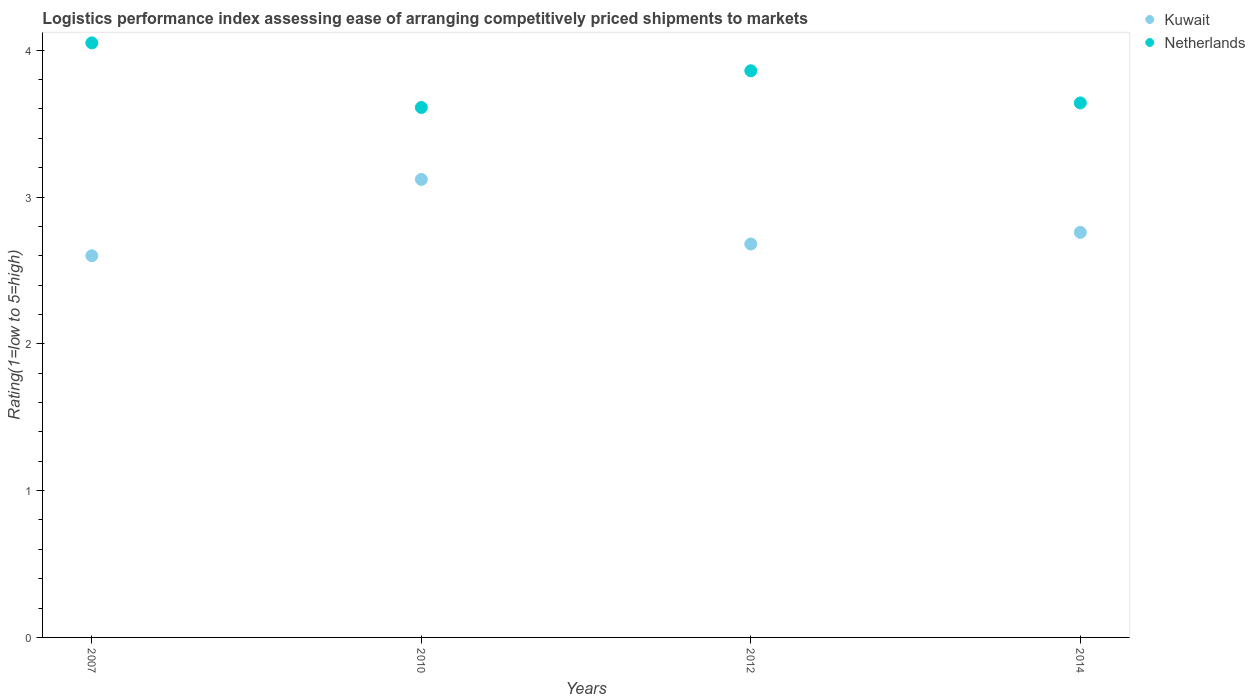How many different coloured dotlines are there?
Provide a short and direct response. 2. What is the Logistic performance index in Netherlands in 2010?
Keep it short and to the point. 3.61. Across all years, what is the maximum Logistic performance index in Kuwait?
Ensure brevity in your answer.  3.12. Across all years, what is the minimum Logistic performance index in Kuwait?
Offer a terse response. 2.6. In which year was the Logistic performance index in Netherlands minimum?
Offer a terse response. 2010. What is the total Logistic performance index in Kuwait in the graph?
Make the answer very short. 11.16. What is the difference between the Logistic performance index in Kuwait in 2012 and that in 2014?
Offer a terse response. -0.08. What is the difference between the Logistic performance index in Kuwait in 2014 and the Logistic performance index in Netherlands in 2007?
Ensure brevity in your answer.  -1.29. What is the average Logistic performance index in Kuwait per year?
Ensure brevity in your answer.  2.79. In the year 2014, what is the difference between the Logistic performance index in Netherlands and Logistic performance index in Kuwait?
Give a very brief answer. 0.88. What is the ratio of the Logistic performance index in Netherlands in 2010 to that in 2012?
Provide a succinct answer. 0.94. What is the difference between the highest and the second highest Logistic performance index in Netherlands?
Offer a very short reply. 0.19. What is the difference between the highest and the lowest Logistic performance index in Netherlands?
Your response must be concise. 0.44. Is the sum of the Logistic performance index in Netherlands in 2007 and 2012 greater than the maximum Logistic performance index in Kuwait across all years?
Provide a short and direct response. Yes. Is the Logistic performance index in Netherlands strictly greater than the Logistic performance index in Kuwait over the years?
Make the answer very short. Yes. Is the Logistic performance index in Kuwait strictly less than the Logistic performance index in Netherlands over the years?
Your response must be concise. Yes. Are the values on the major ticks of Y-axis written in scientific E-notation?
Provide a succinct answer. No. Does the graph contain grids?
Offer a terse response. No. Where does the legend appear in the graph?
Provide a short and direct response. Top right. What is the title of the graph?
Make the answer very short. Logistics performance index assessing ease of arranging competitively priced shipments to markets. What is the label or title of the X-axis?
Offer a very short reply. Years. What is the label or title of the Y-axis?
Offer a very short reply. Rating(1=low to 5=high). What is the Rating(1=low to 5=high) of Netherlands in 2007?
Ensure brevity in your answer.  4.05. What is the Rating(1=low to 5=high) of Kuwait in 2010?
Offer a very short reply. 3.12. What is the Rating(1=low to 5=high) in Netherlands in 2010?
Your response must be concise. 3.61. What is the Rating(1=low to 5=high) in Kuwait in 2012?
Make the answer very short. 2.68. What is the Rating(1=low to 5=high) in Netherlands in 2012?
Offer a terse response. 3.86. What is the Rating(1=low to 5=high) in Kuwait in 2014?
Offer a very short reply. 2.76. What is the Rating(1=low to 5=high) of Netherlands in 2014?
Make the answer very short. 3.64. Across all years, what is the maximum Rating(1=low to 5=high) in Kuwait?
Keep it short and to the point. 3.12. Across all years, what is the maximum Rating(1=low to 5=high) of Netherlands?
Offer a very short reply. 4.05. Across all years, what is the minimum Rating(1=low to 5=high) of Kuwait?
Your response must be concise. 2.6. Across all years, what is the minimum Rating(1=low to 5=high) in Netherlands?
Ensure brevity in your answer.  3.61. What is the total Rating(1=low to 5=high) of Kuwait in the graph?
Provide a succinct answer. 11.16. What is the total Rating(1=low to 5=high) of Netherlands in the graph?
Provide a short and direct response. 15.16. What is the difference between the Rating(1=low to 5=high) in Kuwait in 2007 and that in 2010?
Your answer should be very brief. -0.52. What is the difference between the Rating(1=low to 5=high) in Netherlands in 2007 and that in 2010?
Ensure brevity in your answer.  0.44. What is the difference between the Rating(1=low to 5=high) of Kuwait in 2007 and that in 2012?
Your response must be concise. -0.08. What is the difference between the Rating(1=low to 5=high) in Netherlands in 2007 and that in 2012?
Provide a succinct answer. 0.19. What is the difference between the Rating(1=low to 5=high) in Kuwait in 2007 and that in 2014?
Give a very brief answer. -0.16. What is the difference between the Rating(1=low to 5=high) of Netherlands in 2007 and that in 2014?
Provide a succinct answer. 0.41. What is the difference between the Rating(1=low to 5=high) of Kuwait in 2010 and that in 2012?
Provide a short and direct response. 0.44. What is the difference between the Rating(1=low to 5=high) of Netherlands in 2010 and that in 2012?
Offer a terse response. -0.25. What is the difference between the Rating(1=low to 5=high) of Kuwait in 2010 and that in 2014?
Make the answer very short. 0.36. What is the difference between the Rating(1=low to 5=high) of Netherlands in 2010 and that in 2014?
Your response must be concise. -0.03. What is the difference between the Rating(1=low to 5=high) of Kuwait in 2012 and that in 2014?
Provide a short and direct response. -0.08. What is the difference between the Rating(1=low to 5=high) in Netherlands in 2012 and that in 2014?
Provide a short and direct response. 0.22. What is the difference between the Rating(1=low to 5=high) in Kuwait in 2007 and the Rating(1=low to 5=high) in Netherlands in 2010?
Ensure brevity in your answer.  -1.01. What is the difference between the Rating(1=low to 5=high) of Kuwait in 2007 and the Rating(1=low to 5=high) of Netherlands in 2012?
Your answer should be very brief. -1.26. What is the difference between the Rating(1=low to 5=high) of Kuwait in 2007 and the Rating(1=low to 5=high) of Netherlands in 2014?
Offer a very short reply. -1.04. What is the difference between the Rating(1=low to 5=high) of Kuwait in 2010 and the Rating(1=low to 5=high) of Netherlands in 2012?
Your answer should be compact. -0.74. What is the difference between the Rating(1=low to 5=high) of Kuwait in 2010 and the Rating(1=low to 5=high) of Netherlands in 2014?
Keep it short and to the point. -0.52. What is the difference between the Rating(1=low to 5=high) in Kuwait in 2012 and the Rating(1=low to 5=high) in Netherlands in 2014?
Offer a very short reply. -0.96. What is the average Rating(1=low to 5=high) of Kuwait per year?
Offer a terse response. 2.79. What is the average Rating(1=low to 5=high) of Netherlands per year?
Ensure brevity in your answer.  3.79. In the year 2007, what is the difference between the Rating(1=low to 5=high) in Kuwait and Rating(1=low to 5=high) in Netherlands?
Provide a succinct answer. -1.45. In the year 2010, what is the difference between the Rating(1=low to 5=high) in Kuwait and Rating(1=low to 5=high) in Netherlands?
Make the answer very short. -0.49. In the year 2012, what is the difference between the Rating(1=low to 5=high) of Kuwait and Rating(1=low to 5=high) of Netherlands?
Give a very brief answer. -1.18. In the year 2014, what is the difference between the Rating(1=low to 5=high) in Kuwait and Rating(1=low to 5=high) in Netherlands?
Your answer should be compact. -0.88. What is the ratio of the Rating(1=low to 5=high) of Kuwait in 2007 to that in 2010?
Offer a very short reply. 0.83. What is the ratio of the Rating(1=low to 5=high) in Netherlands in 2007 to that in 2010?
Ensure brevity in your answer.  1.12. What is the ratio of the Rating(1=low to 5=high) in Kuwait in 2007 to that in 2012?
Provide a succinct answer. 0.97. What is the ratio of the Rating(1=low to 5=high) in Netherlands in 2007 to that in 2012?
Offer a very short reply. 1.05. What is the ratio of the Rating(1=low to 5=high) of Kuwait in 2007 to that in 2014?
Your answer should be very brief. 0.94. What is the ratio of the Rating(1=low to 5=high) in Netherlands in 2007 to that in 2014?
Provide a short and direct response. 1.11. What is the ratio of the Rating(1=low to 5=high) in Kuwait in 2010 to that in 2012?
Your response must be concise. 1.16. What is the ratio of the Rating(1=low to 5=high) of Netherlands in 2010 to that in 2012?
Offer a very short reply. 0.94. What is the ratio of the Rating(1=low to 5=high) in Kuwait in 2010 to that in 2014?
Ensure brevity in your answer.  1.13. What is the ratio of the Rating(1=low to 5=high) of Kuwait in 2012 to that in 2014?
Offer a very short reply. 0.97. What is the ratio of the Rating(1=low to 5=high) in Netherlands in 2012 to that in 2014?
Offer a terse response. 1.06. What is the difference between the highest and the second highest Rating(1=low to 5=high) in Kuwait?
Provide a succinct answer. 0.36. What is the difference between the highest and the second highest Rating(1=low to 5=high) of Netherlands?
Your answer should be very brief. 0.19. What is the difference between the highest and the lowest Rating(1=low to 5=high) of Kuwait?
Provide a succinct answer. 0.52. What is the difference between the highest and the lowest Rating(1=low to 5=high) of Netherlands?
Provide a succinct answer. 0.44. 